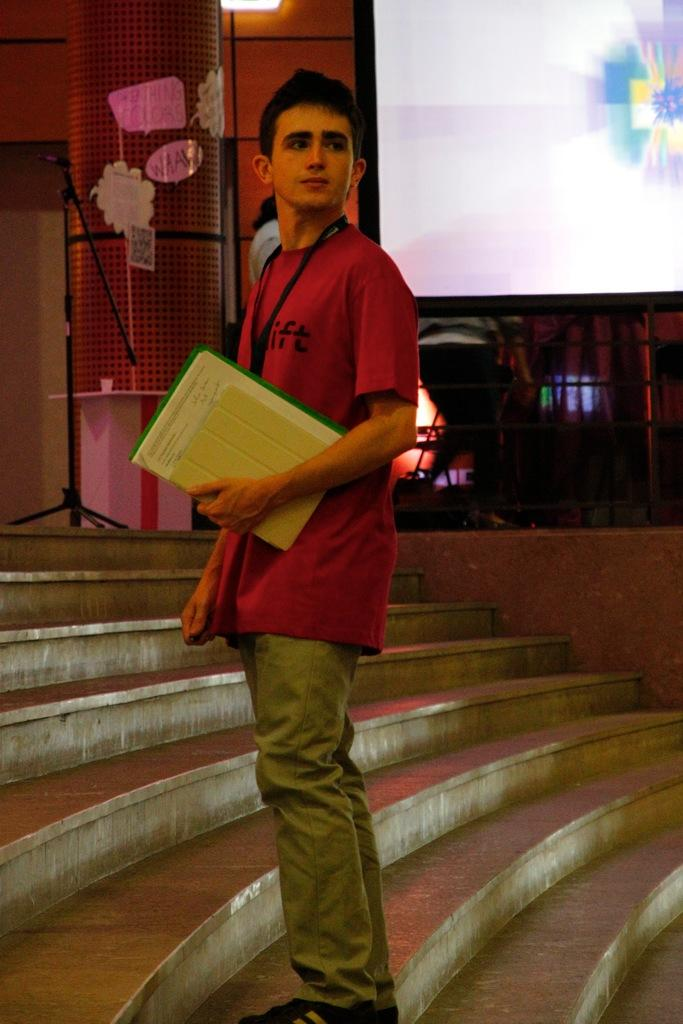What is the main subject of the image? There is a man standing in the image. What is the man holding in his hand? The man is holding objects in his hand. What can be seen in the background of the image? There is a projector screen and lights in the background of the image. Are there any other objects visible in the background? Yes, there are other unspecified objects in the background of the image. What type of meat is hanging from the branch in the image? There is no meat or branch present in the image. How does the sand affect the man's ability to hold the objects in the image? There is no sand present in the image, so it does not affect the man's ability to hold the objects. 